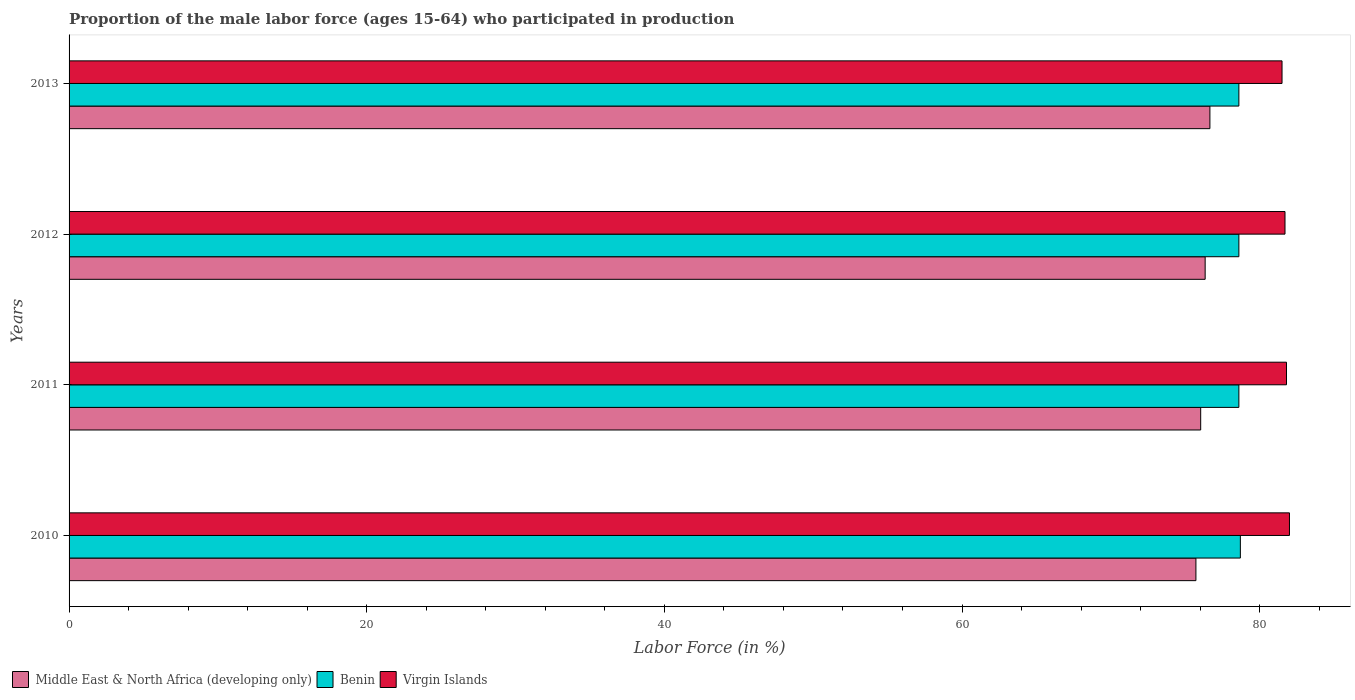Are the number of bars per tick equal to the number of legend labels?
Provide a succinct answer. Yes. How many bars are there on the 2nd tick from the top?
Keep it short and to the point. 3. How many bars are there on the 2nd tick from the bottom?
Provide a succinct answer. 3. In how many cases, is the number of bars for a given year not equal to the number of legend labels?
Provide a succinct answer. 0. What is the proportion of the male labor force who participated in production in Middle East & North Africa (developing only) in 2013?
Ensure brevity in your answer.  76.65. Across all years, what is the maximum proportion of the male labor force who participated in production in Middle East & North Africa (developing only)?
Your response must be concise. 76.65. Across all years, what is the minimum proportion of the male labor force who participated in production in Benin?
Offer a terse response. 78.6. In which year was the proportion of the male labor force who participated in production in Middle East & North Africa (developing only) maximum?
Provide a succinct answer. 2013. In which year was the proportion of the male labor force who participated in production in Benin minimum?
Make the answer very short. 2011. What is the total proportion of the male labor force who participated in production in Virgin Islands in the graph?
Provide a short and direct response. 327. What is the difference between the proportion of the male labor force who participated in production in Benin in 2011 and the proportion of the male labor force who participated in production in Middle East & North Africa (developing only) in 2012?
Keep it short and to the point. 2.27. What is the average proportion of the male labor force who participated in production in Virgin Islands per year?
Provide a short and direct response. 81.75. In the year 2013, what is the difference between the proportion of the male labor force who participated in production in Benin and proportion of the male labor force who participated in production in Middle East & North Africa (developing only)?
Provide a short and direct response. 1.95. What is the ratio of the proportion of the male labor force who participated in production in Virgin Islands in 2010 to that in 2011?
Give a very brief answer. 1. Is the difference between the proportion of the male labor force who participated in production in Benin in 2010 and 2013 greater than the difference between the proportion of the male labor force who participated in production in Middle East & North Africa (developing only) in 2010 and 2013?
Offer a very short reply. Yes. What is the difference between the highest and the second highest proportion of the male labor force who participated in production in Benin?
Ensure brevity in your answer.  0.1. What is the difference between the highest and the lowest proportion of the male labor force who participated in production in Virgin Islands?
Offer a very short reply. 0.5. Is the sum of the proportion of the male labor force who participated in production in Middle East & North Africa (developing only) in 2010 and 2013 greater than the maximum proportion of the male labor force who participated in production in Benin across all years?
Your response must be concise. Yes. What does the 2nd bar from the top in 2011 represents?
Your response must be concise. Benin. What does the 2nd bar from the bottom in 2010 represents?
Your answer should be very brief. Benin. How many bars are there?
Make the answer very short. 12. How many years are there in the graph?
Keep it short and to the point. 4. Where does the legend appear in the graph?
Ensure brevity in your answer.  Bottom left. What is the title of the graph?
Provide a succinct answer. Proportion of the male labor force (ages 15-64) who participated in production. Does "Europe(developing only)" appear as one of the legend labels in the graph?
Your response must be concise. No. What is the label or title of the Y-axis?
Ensure brevity in your answer.  Years. What is the Labor Force (in %) in Middle East & North Africa (developing only) in 2010?
Your response must be concise. 75.71. What is the Labor Force (in %) in Benin in 2010?
Offer a very short reply. 78.7. What is the Labor Force (in %) in Middle East & North Africa (developing only) in 2011?
Offer a terse response. 76.03. What is the Labor Force (in %) in Benin in 2011?
Your response must be concise. 78.6. What is the Labor Force (in %) in Virgin Islands in 2011?
Offer a very short reply. 81.8. What is the Labor Force (in %) in Middle East & North Africa (developing only) in 2012?
Provide a short and direct response. 76.33. What is the Labor Force (in %) in Benin in 2012?
Provide a short and direct response. 78.6. What is the Labor Force (in %) of Virgin Islands in 2012?
Your answer should be very brief. 81.7. What is the Labor Force (in %) of Middle East & North Africa (developing only) in 2013?
Provide a succinct answer. 76.65. What is the Labor Force (in %) of Benin in 2013?
Offer a terse response. 78.6. What is the Labor Force (in %) of Virgin Islands in 2013?
Your response must be concise. 81.5. Across all years, what is the maximum Labor Force (in %) in Middle East & North Africa (developing only)?
Offer a very short reply. 76.65. Across all years, what is the maximum Labor Force (in %) of Benin?
Provide a succinct answer. 78.7. Across all years, what is the minimum Labor Force (in %) of Middle East & North Africa (developing only)?
Make the answer very short. 75.71. Across all years, what is the minimum Labor Force (in %) of Benin?
Ensure brevity in your answer.  78.6. Across all years, what is the minimum Labor Force (in %) in Virgin Islands?
Offer a very short reply. 81.5. What is the total Labor Force (in %) in Middle East & North Africa (developing only) in the graph?
Keep it short and to the point. 304.74. What is the total Labor Force (in %) in Benin in the graph?
Make the answer very short. 314.5. What is the total Labor Force (in %) of Virgin Islands in the graph?
Your answer should be very brief. 327. What is the difference between the Labor Force (in %) in Middle East & North Africa (developing only) in 2010 and that in 2011?
Keep it short and to the point. -0.32. What is the difference between the Labor Force (in %) of Benin in 2010 and that in 2011?
Your response must be concise. 0.1. What is the difference between the Labor Force (in %) in Virgin Islands in 2010 and that in 2011?
Provide a succinct answer. 0.2. What is the difference between the Labor Force (in %) of Middle East & North Africa (developing only) in 2010 and that in 2012?
Your response must be concise. -0.62. What is the difference between the Labor Force (in %) in Benin in 2010 and that in 2012?
Your response must be concise. 0.1. What is the difference between the Labor Force (in %) in Middle East & North Africa (developing only) in 2010 and that in 2013?
Offer a terse response. -0.94. What is the difference between the Labor Force (in %) in Middle East & North Africa (developing only) in 2011 and that in 2012?
Keep it short and to the point. -0.3. What is the difference between the Labor Force (in %) of Benin in 2011 and that in 2012?
Offer a very short reply. 0. What is the difference between the Labor Force (in %) in Middle East & North Africa (developing only) in 2011 and that in 2013?
Your answer should be very brief. -0.62. What is the difference between the Labor Force (in %) of Benin in 2011 and that in 2013?
Keep it short and to the point. 0. What is the difference between the Labor Force (in %) in Middle East & North Africa (developing only) in 2012 and that in 2013?
Keep it short and to the point. -0.32. What is the difference between the Labor Force (in %) in Benin in 2012 and that in 2013?
Your answer should be very brief. 0. What is the difference between the Labor Force (in %) of Virgin Islands in 2012 and that in 2013?
Your answer should be very brief. 0.2. What is the difference between the Labor Force (in %) in Middle East & North Africa (developing only) in 2010 and the Labor Force (in %) in Benin in 2011?
Provide a short and direct response. -2.89. What is the difference between the Labor Force (in %) in Middle East & North Africa (developing only) in 2010 and the Labor Force (in %) in Virgin Islands in 2011?
Keep it short and to the point. -6.09. What is the difference between the Labor Force (in %) in Benin in 2010 and the Labor Force (in %) in Virgin Islands in 2011?
Make the answer very short. -3.1. What is the difference between the Labor Force (in %) in Middle East & North Africa (developing only) in 2010 and the Labor Force (in %) in Benin in 2012?
Ensure brevity in your answer.  -2.89. What is the difference between the Labor Force (in %) of Middle East & North Africa (developing only) in 2010 and the Labor Force (in %) of Virgin Islands in 2012?
Ensure brevity in your answer.  -5.99. What is the difference between the Labor Force (in %) in Middle East & North Africa (developing only) in 2010 and the Labor Force (in %) in Benin in 2013?
Give a very brief answer. -2.89. What is the difference between the Labor Force (in %) of Middle East & North Africa (developing only) in 2010 and the Labor Force (in %) of Virgin Islands in 2013?
Offer a very short reply. -5.79. What is the difference between the Labor Force (in %) in Middle East & North Africa (developing only) in 2011 and the Labor Force (in %) in Benin in 2012?
Ensure brevity in your answer.  -2.57. What is the difference between the Labor Force (in %) in Middle East & North Africa (developing only) in 2011 and the Labor Force (in %) in Virgin Islands in 2012?
Your response must be concise. -5.67. What is the difference between the Labor Force (in %) of Middle East & North Africa (developing only) in 2011 and the Labor Force (in %) of Benin in 2013?
Your answer should be very brief. -2.57. What is the difference between the Labor Force (in %) in Middle East & North Africa (developing only) in 2011 and the Labor Force (in %) in Virgin Islands in 2013?
Offer a very short reply. -5.47. What is the difference between the Labor Force (in %) in Middle East & North Africa (developing only) in 2012 and the Labor Force (in %) in Benin in 2013?
Offer a terse response. -2.27. What is the difference between the Labor Force (in %) of Middle East & North Africa (developing only) in 2012 and the Labor Force (in %) of Virgin Islands in 2013?
Your answer should be very brief. -5.17. What is the difference between the Labor Force (in %) of Benin in 2012 and the Labor Force (in %) of Virgin Islands in 2013?
Your response must be concise. -2.9. What is the average Labor Force (in %) of Middle East & North Africa (developing only) per year?
Your answer should be very brief. 76.18. What is the average Labor Force (in %) in Benin per year?
Ensure brevity in your answer.  78.62. What is the average Labor Force (in %) of Virgin Islands per year?
Your answer should be very brief. 81.75. In the year 2010, what is the difference between the Labor Force (in %) in Middle East & North Africa (developing only) and Labor Force (in %) in Benin?
Your answer should be very brief. -2.99. In the year 2010, what is the difference between the Labor Force (in %) in Middle East & North Africa (developing only) and Labor Force (in %) in Virgin Islands?
Offer a very short reply. -6.29. In the year 2010, what is the difference between the Labor Force (in %) of Benin and Labor Force (in %) of Virgin Islands?
Provide a short and direct response. -3.3. In the year 2011, what is the difference between the Labor Force (in %) in Middle East & North Africa (developing only) and Labor Force (in %) in Benin?
Offer a very short reply. -2.57. In the year 2011, what is the difference between the Labor Force (in %) of Middle East & North Africa (developing only) and Labor Force (in %) of Virgin Islands?
Provide a succinct answer. -5.77. In the year 2011, what is the difference between the Labor Force (in %) in Benin and Labor Force (in %) in Virgin Islands?
Give a very brief answer. -3.2. In the year 2012, what is the difference between the Labor Force (in %) of Middle East & North Africa (developing only) and Labor Force (in %) of Benin?
Give a very brief answer. -2.27. In the year 2012, what is the difference between the Labor Force (in %) of Middle East & North Africa (developing only) and Labor Force (in %) of Virgin Islands?
Your answer should be compact. -5.37. In the year 2013, what is the difference between the Labor Force (in %) in Middle East & North Africa (developing only) and Labor Force (in %) in Benin?
Offer a terse response. -1.95. In the year 2013, what is the difference between the Labor Force (in %) in Middle East & North Africa (developing only) and Labor Force (in %) in Virgin Islands?
Ensure brevity in your answer.  -4.85. What is the ratio of the Labor Force (in %) in Benin in 2010 to that in 2011?
Give a very brief answer. 1. What is the ratio of the Labor Force (in %) in Benin in 2010 to that in 2012?
Provide a succinct answer. 1. What is the ratio of the Labor Force (in %) in Middle East & North Africa (developing only) in 2010 to that in 2013?
Offer a very short reply. 0.99. What is the ratio of the Labor Force (in %) in Virgin Islands in 2010 to that in 2013?
Keep it short and to the point. 1.01. What is the ratio of the Labor Force (in %) in Virgin Islands in 2011 to that in 2013?
Ensure brevity in your answer.  1. What is the ratio of the Labor Force (in %) in Middle East & North Africa (developing only) in 2012 to that in 2013?
Provide a succinct answer. 1. What is the difference between the highest and the second highest Labor Force (in %) in Middle East & North Africa (developing only)?
Your response must be concise. 0.32. What is the difference between the highest and the second highest Labor Force (in %) of Virgin Islands?
Provide a short and direct response. 0.2. What is the difference between the highest and the lowest Labor Force (in %) in Middle East & North Africa (developing only)?
Provide a short and direct response. 0.94. What is the difference between the highest and the lowest Labor Force (in %) in Benin?
Your answer should be very brief. 0.1. What is the difference between the highest and the lowest Labor Force (in %) of Virgin Islands?
Offer a very short reply. 0.5. 